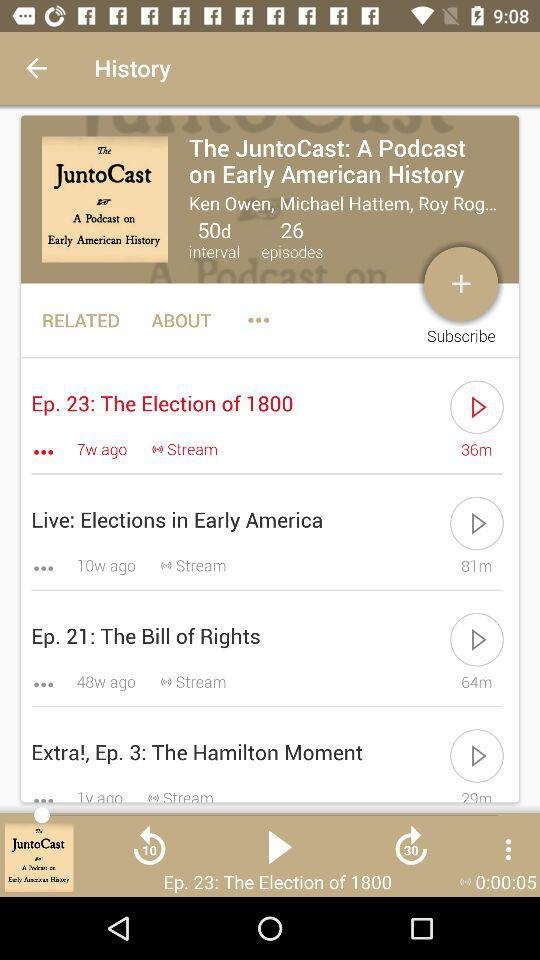How many episodes are there in the JuntoCast podcast?
Answer the question using a single word or phrase. 4 